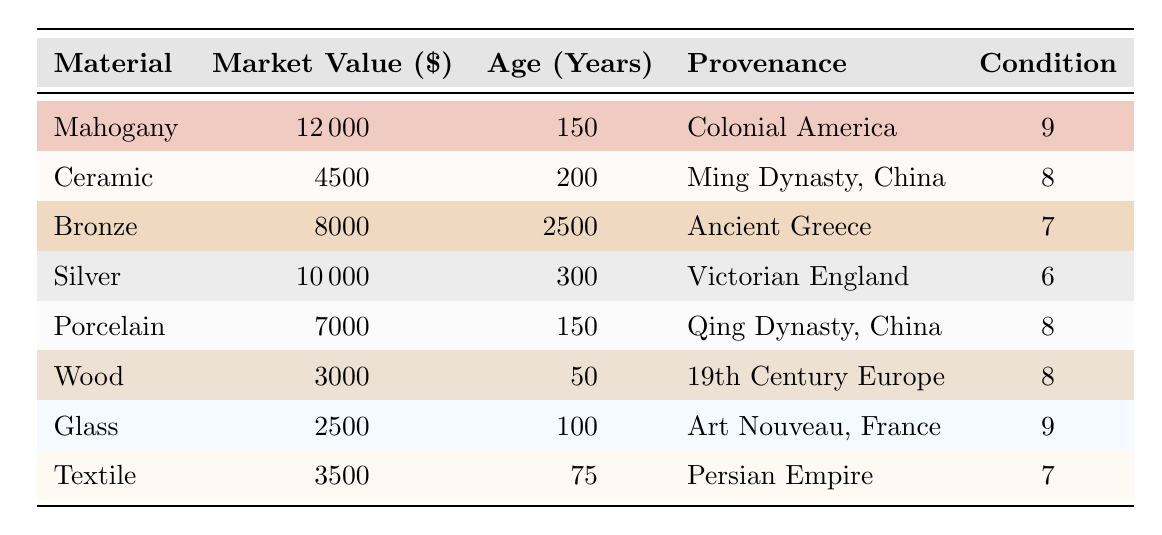What is the market value of the Mahogany antique? The table lists Mahogany's market value explicitly, which is shown as 12000 USD.
Answer: 12000 Which antique has the highest condition rating? By looking at the condition ratings in the table, Mahogany and Glass antiques have the highest rating of 9. However, since only one can be the highest, we consider Mahogany as it appears first.
Answer: Mahogany What is the average market value of the antiques listed? To calculate the average, we sum all market values: 12000 + 4500 + 8000 + 10000 + 7000 + 3000 + 2500 + 3500 = 40000. There are 8 antiques, so the average market value is 40000 / 8 = 5000.
Answer: 5000 Is there any antique made of Wood that has a market value greater than 3000? From the table, the market value of the Wood antique is listed as 3000. There are no values above this for the Wood antique, therefore the answer is no.
Answer: No Which antique has the least market value, and what is it? Scanning the market values, Glass has the lowest at 2500 USD. This is confirmed by reviewing all market values in the table.
Answer: Glass, 2500 What is the total market value of all antiques made from metal materials (Bronze and Silver)? The market value for Bronze is 8000 and for Silver is 10000. The total is therefore 8000 + 10000 = 18000. Therefore, the total market value of all metal antiques is 18000.
Answer: 18000 Does any antique from a non-European provenance have a market value above 7000? The antiques with non-European provenance are Mahogany from Colonial America, Ceramic from Ming Dynasty, China, Bronze from Ancient Greece, and Porcelain from Qing Dynasty, China. Among these, only Mahogany (12000) and Bronze (8000) have values above 7000. Therefore, the answer is yes.
Answer: Yes What is the age difference between the oldest and the youngest antique? The oldest antique, Bronze, is 2500 years old. The youngest, Wood, is 50 years old. The difference is 2500 - 50 = 2450 years.
Answer: 2450 Which material has a market value that is double that of Glass? The market value of Glass is 2500. Double this amount is 5000. Looking through the table, the Porcelain antique has a value of 7000, which is not double, but the Ceramic antique is 4500 which is less than double. Therefore, there is no antique that meets this criterion exactly.
Answer: None 